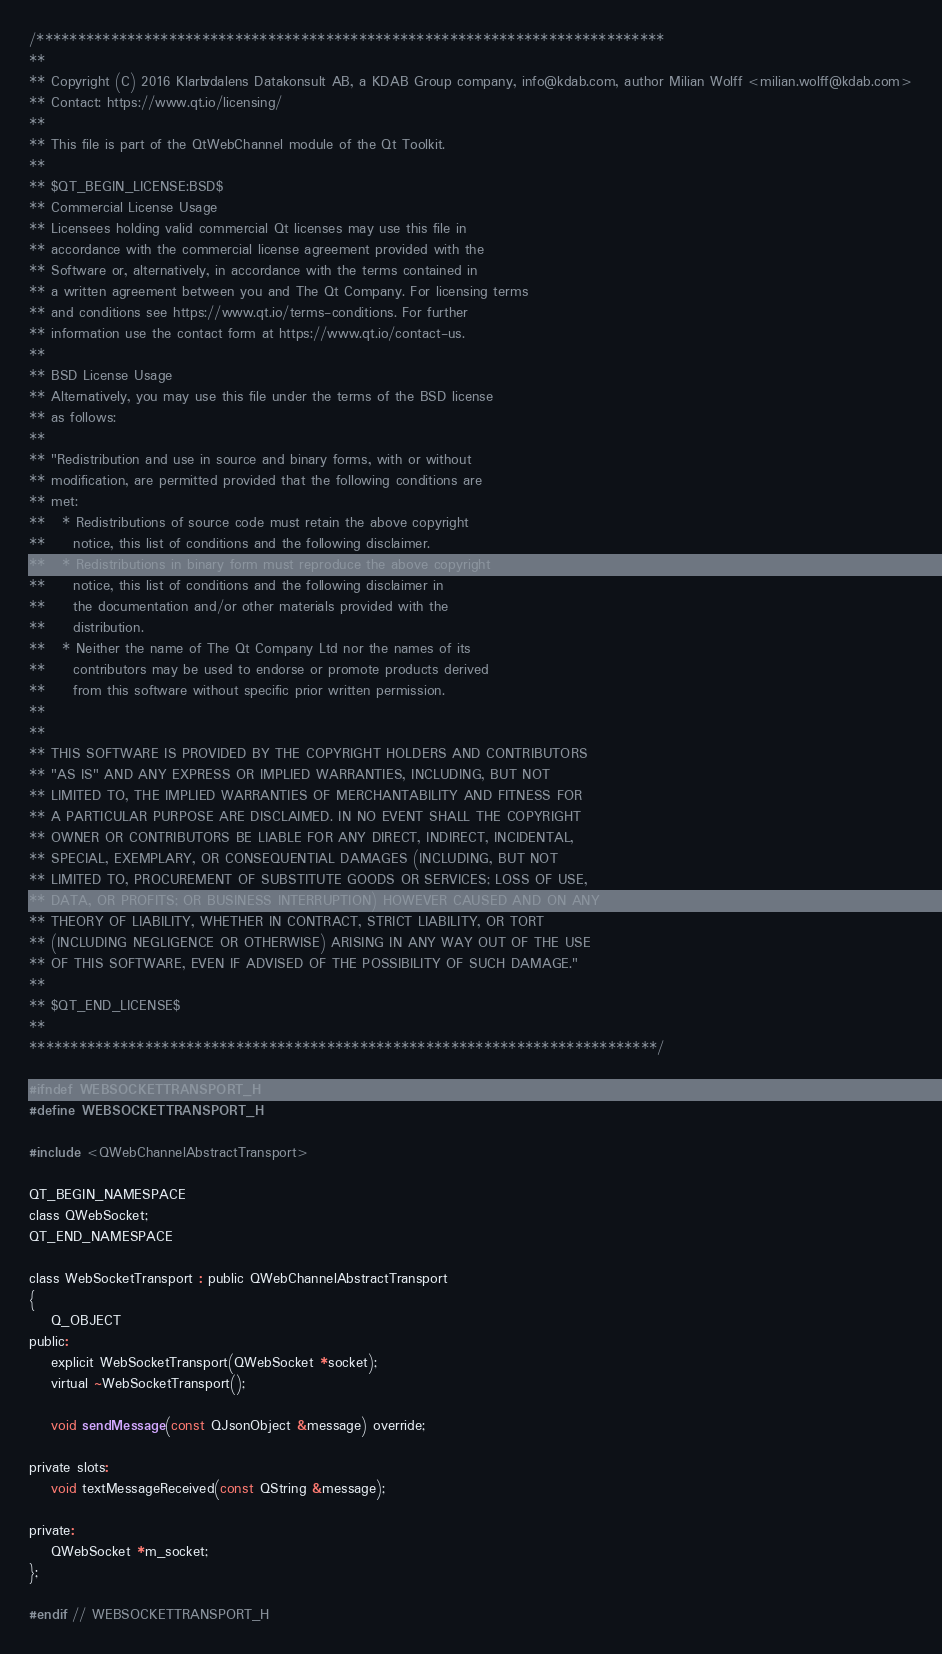Convert code to text. <code><loc_0><loc_0><loc_500><loc_500><_C_>/****************************************************************************
**
** Copyright (C) 2016 Klarälvdalens Datakonsult AB, a KDAB Group company, info@kdab.com, author Milian Wolff <milian.wolff@kdab.com>
** Contact: https://www.qt.io/licensing/
**
** This file is part of the QtWebChannel module of the Qt Toolkit.
**
** $QT_BEGIN_LICENSE:BSD$
** Commercial License Usage
** Licensees holding valid commercial Qt licenses may use this file in
** accordance with the commercial license agreement provided with the
** Software or, alternatively, in accordance with the terms contained in
** a written agreement between you and The Qt Company. For licensing terms
** and conditions see https://www.qt.io/terms-conditions. For further
** information use the contact form at https://www.qt.io/contact-us.
**
** BSD License Usage
** Alternatively, you may use this file under the terms of the BSD license
** as follows:
**
** "Redistribution and use in source and binary forms, with or without
** modification, are permitted provided that the following conditions are
** met:
**   * Redistributions of source code must retain the above copyright
**     notice, this list of conditions and the following disclaimer.
**   * Redistributions in binary form must reproduce the above copyright
**     notice, this list of conditions and the following disclaimer in
**     the documentation and/or other materials provided with the
**     distribution.
**   * Neither the name of The Qt Company Ltd nor the names of its
**     contributors may be used to endorse or promote products derived
**     from this software without specific prior written permission.
**
**
** THIS SOFTWARE IS PROVIDED BY THE COPYRIGHT HOLDERS AND CONTRIBUTORS
** "AS IS" AND ANY EXPRESS OR IMPLIED WARRANTIES, INCLUDING, BUT NOT
** LIMITED TO, THE IMPLIED WARRANTIES OF MERCHANTABILITY AND FITNESS FOR
** A PARTICULAR PURPOSE ARE DISCLAIMED. IN NO EVENT SHALL THE COPYRIGHT
** OWNER OR CONTRIBUTORS BE LIABLE FOR ANY DIRECT, INDIRECT, INCIDENTAL,
** SPECIAL, EXEMPLARY, OR CONSEQUENTIAL DAMAGES (INCLUDING, BUT NOT
** LIMITED TO, PROCUREMENT OF SUBSTITUTE GOODS OR SERVICES; LOSS OF USE,
** DATA, OR PROFITS; OR BUSINESS INTERRUPTION) HOWEVER CAUSED AND ON ANY
** THEORY OF LIABILITY, WHETHER IN CONTRACT, STRICT LIABILITY, OR TORT
** (INCLUDING NEGLIGENCE OR OTHERWISE) ARISING IN ANY WAY OUT OF THE USE
** OF THIS SOFTWARE, EVEN IF ADVISED OF THE POSSIBILITY OF SUCH DAMAGE."
**
** $QT_END_LICENSE$
**
****************************************************************************/

#ifndef WEBSOCKETTRANSPORT_H
#define WEBSOCKETTRANSPORT_H

#include <QWebChannelAbstractTransport>

QT_BEGIN_NAMESPACE
class QWebSocket;
QT_END_NAMESPACE

class WebSocketTransport : public QWebChannelAbstractTransport
{
    Q_OBJECT
public:
    explicit WebSocketTransport(QWebSocket *socket);
    virtual ~WebSocketTransport();

    void sendMessage(const QJsonObject &message) override;

private slots:
    void textMessageReceived(const QString &message);

private:
    QWebSocket *m_socket;
};

#endif // WEBSOCKETTRANSPORT_H
</code> 